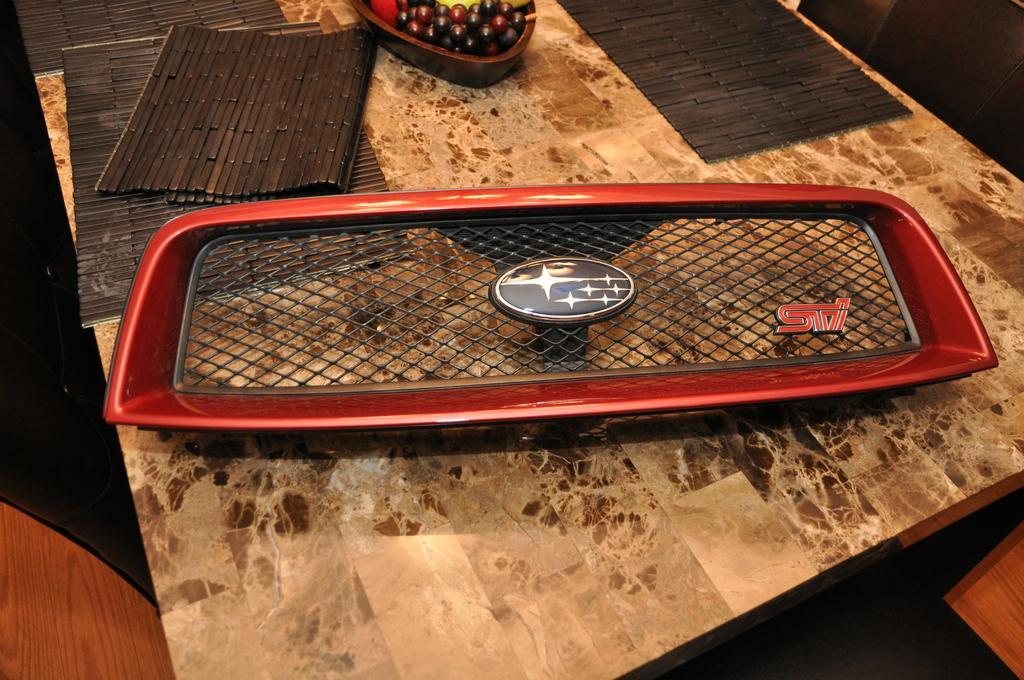In one or two sentences, can you explain what this image depicts? In this picture we can see an object on the table and on the table there are table mats and a bowl with fruits. 